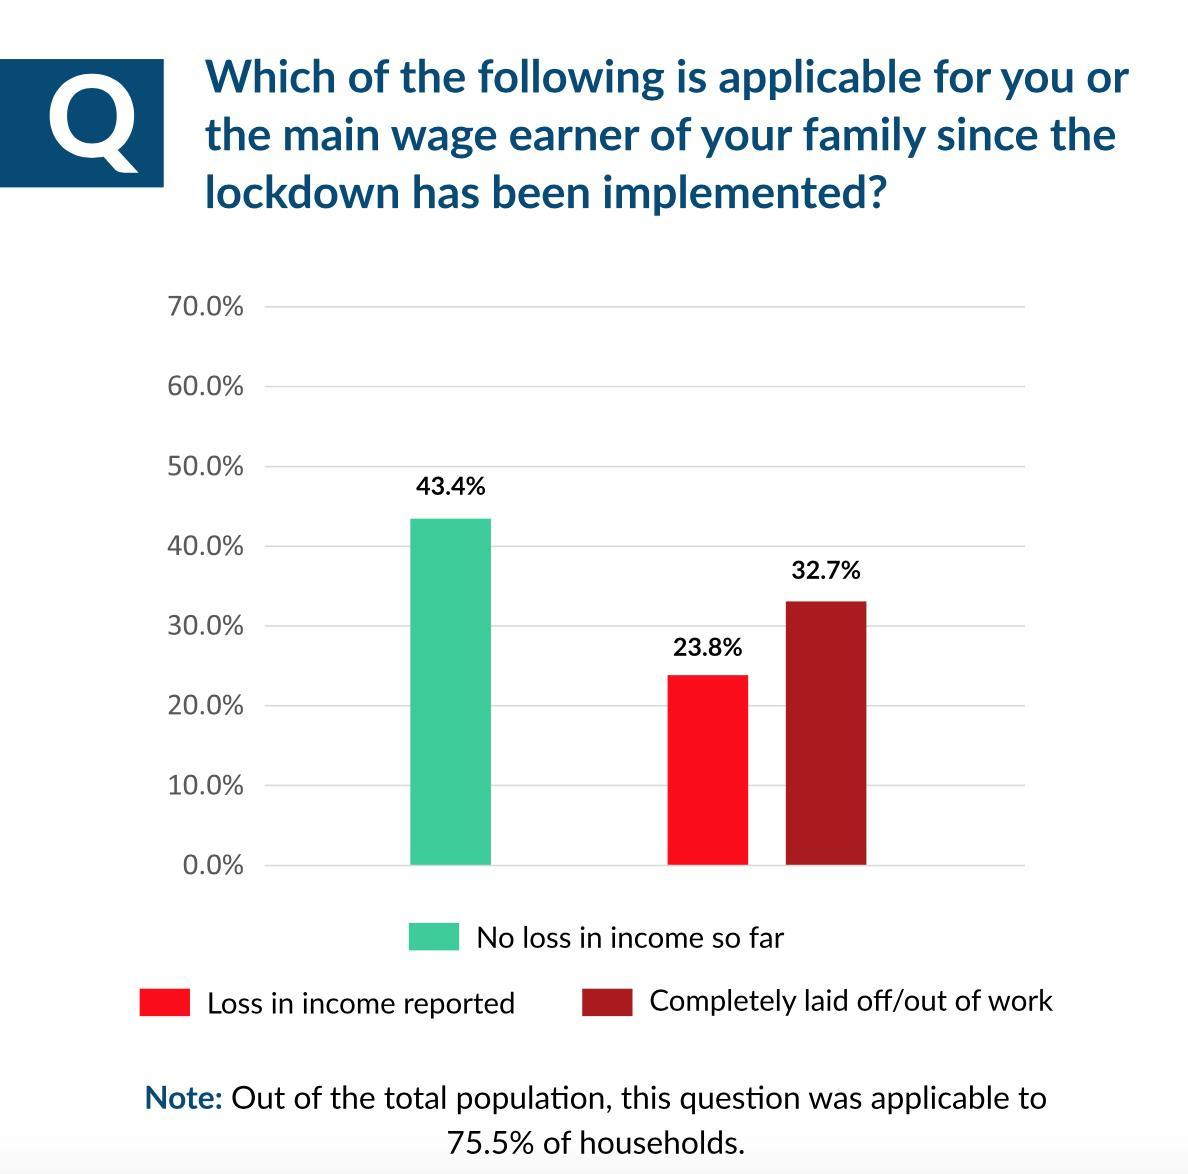What percentage of respondents reported no loss in income so far since the lockdown has been implemented?
Answer the question with a short phrase. 43.4% What percentage of respondents reported that they are completely out of work since the lockdown has been implemented? 32.7% What percentage of respondents reported loss in income since the lockdown has been implemented? 23.8% 